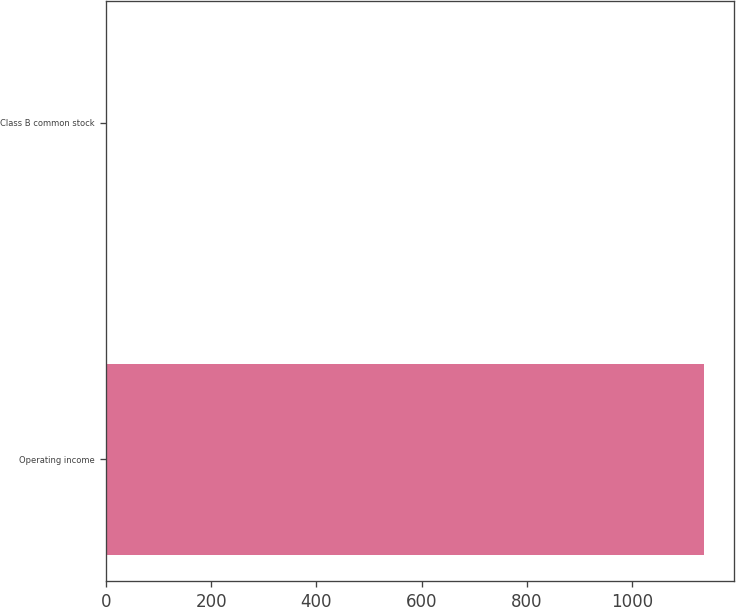Convert chart. <chart><loc_0><loc_0><loc_500><loc_500><bar_chart><fcel>Operating income<fcel>Class B common stock<nl><fcel>1137<fcel>0.56<nl></chart> 